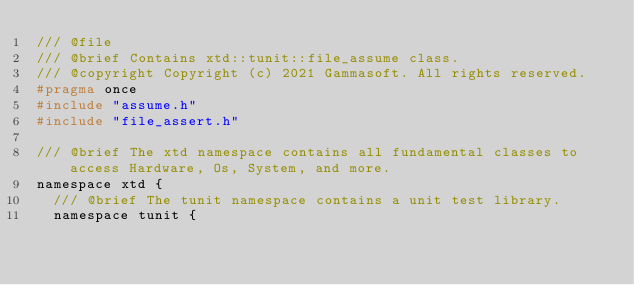Convert code to text. <code><loc_0><loc_0><loc_500><loc_500><_C_>/// @file
/// @brief Contains xtd::tunit::file_assume class.
/// @copyright Copyright (c) 2021 Gammasoft. All rights reserved.
#pragma once
#include "assume.h"
#include "file_assert.h"

/// @brief The xtd namespace contains all fundamental classes to access Hardware, Os, System, and more.
namespace xtd {
  /// @brief The tunit namespace contains a unit test library.
  namespace tunit {</code> 